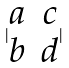<formula> <loc_0><loc_0><loc_500><loc_500>| \begin{matrix} a & c \\ b & d \end{matrix} |</formula> 